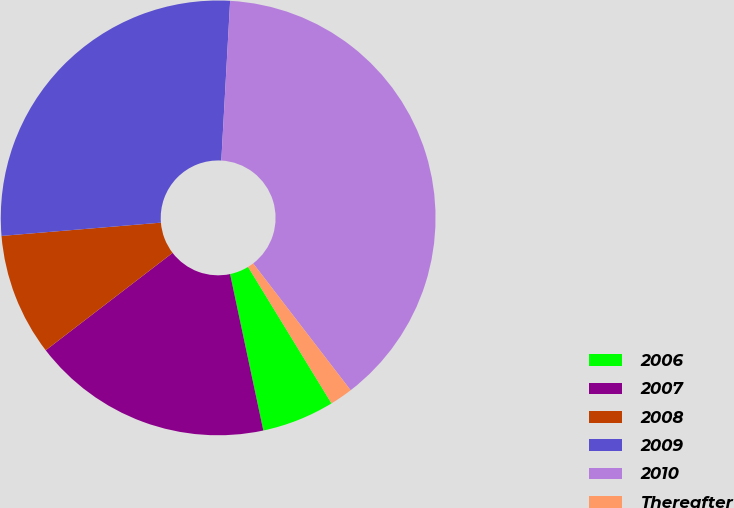Convert chart. <chart><loc_0><loc_0><loc_500><loc_500><pie_chart><fcel>2006<fcel>2007<fcel>2008<fcel>2009<fcel>2010<fcel>Thereafter<nl><fcel>5.4%<fcel>17.91%<fcel>9.1%<fcel>27.2%<fcel>38.69%<fcel>1.7%<nl></chart> 